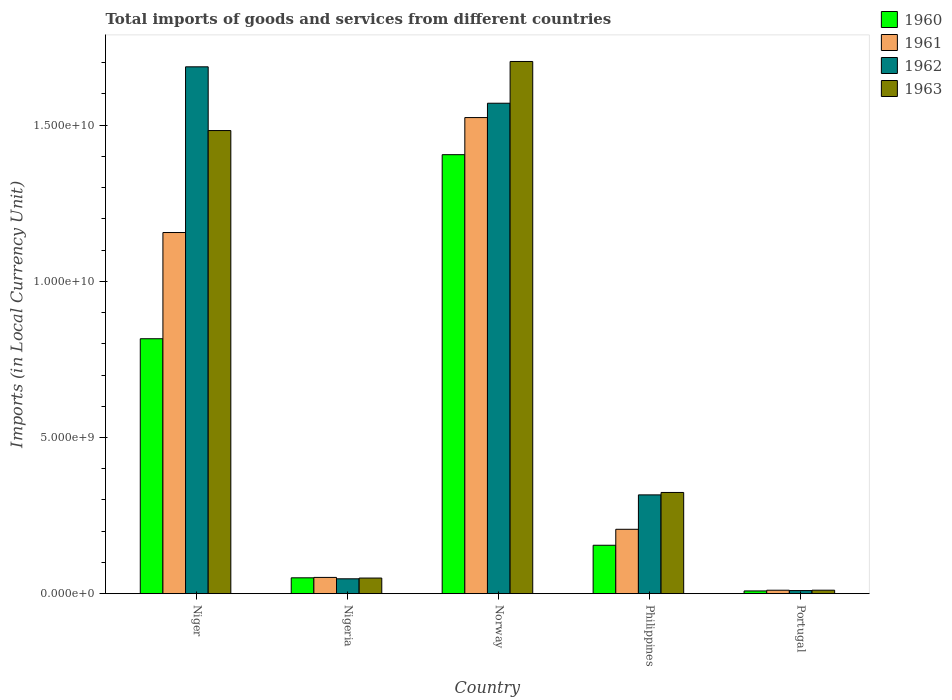How many different coloured bars are there?
Keep it short and to the point. 4. Are the number of bars per tick equal to the number of legend labels?
Offer a very short reply. Yes. Are the number of bars on each tick of the X-axis equal?
Keep it short and to the point. Yes. How many bars are there on the 3rd tick from the left?
Your answer should be very brief. 4. What is the label of the 2nd group of bars from the left?
Ensure brevity in your answer.  Nigeria. What is the Amount of goods and services imports in 1963 in Nigeria?
Your response must be concise. 4.99e+08. Across all countries, what is the maximum Amount of goods and services imports in 1962?
Keep it short and to the point. 1.69e+1. Across all countries, what is the minimum Amount of goods and services imports in 1960?
Ensure brevity in your answer.  8.70e+07. In which country was the Amount of goods and services imports in 1962 maximum?
Provide a succinct answer. Niger. In which country was the Amount of goods and services imports in 1963 minimum?
Keep it short and to the point. Portugal. What is the total Amount of goods and services imports in 1962 in the graph?
Your answer should be very brief. 3.63e+1. What is the difference between the Amount of goods and services imports in 1961 in Nigeria and that in Portugal?
Give a very brief answer. 4.10e+08. What is the difference between the Amount of goods and services imports in 1962 in Norway and the Amount of goods and services imports in 1961 in Nigeria?
Offer a very short reply. 1.52e+1. What is the average Amount of goods and services imports in 1961 per country?
Ensure brevity in your answer.  5.90e+09. What is the difference between the Amount of goods and services imports of/in 1963 and Amount of goods and services imports of/in 1961 in Philippines?
Keep it short and to the point. 1.18e+09. What is the ratio of the Amount of goods and services imports in 1960 in Niger to that in Nigeria?
Your answer should be very brief. 16.09. Is the Amount of goods and services imports in 1961 in Nigeria less than that in Norway?
Provide a short and direct response. Yes. What is the difference between the highest and the second highest Amount of goods and services imports in 1963?
Offer a terse response. 2.21e+09. What is the difference between the highest and the lowest Amount of goods and services imports in 1961?
Ensure brevity in your answer.  1.51e+1. In how many countries, is the Amount of goods and services imports in 1961 greater than the average Amount of goods and services imports in 1961 taken over all countries?
Your answer should be very brief. 2. Is the sum of the Amount of goods and services imports in 1962 in Nigeria and Portugal greater than the maximum Amount of goods and services imports in 1963 across all countries?
Give a very brief answer. No. Is it the case that in every country, the sum of the Amount of goods and services imports in 1962 and Amount of goods and services imports in 1963 is greater than the sum of Amount of goods and services imports in 1961 and Amount of goods and services imports in 1960?
Offer a terse response. No. What does the 2nd bar from the right in Norway represents?
Offer a very short reply. 1962. Is it the case that in every country, the sum of the Amount of goods and services imports in 1960 and Amount of goods and services imports in 1962 is greater than the Amount of goods and services imports in 1963?
Your answer should be very brief. Yes. How many countries are there in the graph?
Your response must be concise. 5. What is the difference between two consecutive major ticks on the Y-axis?
Your answer should be compact. 5.00e+09. Are the values on the major ticks of Y-axis written in scientific E-notation?
Provide a succinct answer. Yes. Does the graph contain grids?
Provide a short and direct response. No. Where does the legend appear in the graph?
Offer a very short reply. Top right. How many legend labels are there?
Keep it short and to the point. 4. What is the title of the graph?
Offer a very short reply. Total imports of goods and services from different countries. What is the label or title of the X-axis?
Make the answer very short. Country. What is the label or title of the Y-axis?
Keep it short and to the point. Imports (in Local Currency Unit). What is the Imports (in Local Currency Unit) in 1960 in Niger?
Give a very brief answer. 8.16e+09. What is the Imports (in Local Currency Unit) of 1961 in Niger?
Provide a short and direct response. 1.16e+1. What is the Imports (in Local Currency Unit) of 1962 in Niger?
Offer a terse response. 1.69e+1. What is the Imports (in Local Currency Unit) of 1963 in Niger?
Your answer should be compact. 1.48e+1. What is the Imports (in Local Currency Unit) of 1960 in Nigeria?
Offer a terse response. 5.07e+08. What is the Imports (in Local Currency Unit) in 1961 in Nigeria?
Offer a terse response. 5.20e+08. What is the Imports (in Local Currency Unit) in 1962 in Nigeria?
Your answer should be compact. 4.76e+08. What is the Imports (in Local Currency Unit) of 1963 in Nigeria?
Ensure brevity in your answer.  4.99e+08. What is the Imports (in Local Currency Unit) of 1960 in Norway?
Your answer should be very brief. 1.41e+1. What is the Imports (in Local Currency Unit) in 1961 in Norway?
Offer a very short reply. 1.52e+1. What is the Imports (in Local Currency Unit) of 1962 in Norway?
Keep it short and to the point. 1.57e+1. What is the Imports (in Local Currency Unit) in 1963 in Norway?
Your answer should be very brief. 1.70e+1. What is the Imports (in Local Currency Unit) of 1960 in Philippines?
Provide a succinct answer. 1.55e+09. What is the Imports (in Local Currency Unit) of 1961 in Philippines?
Ensure brevity in your answer.  2.06e+09. What is the Imports (in Local Currency Unit) in 1962 in Philippines?
Offer a very short reply. 3.16e+09. What is the Imports (in Local Currency Unit) in 1963 in Philippines?
Give a very brief answer. 3.24e+09. What is the Imports (in Local Currency Unit) of 1960 in Portugal?
Provide a succinct answer. 8.70e+07. What is the Imports (in Local Currency Unit) of 1961 in Portugal?
Give a very brief answer. 1.10e+08. What is the Imports (in Local Currency Unit) of 1962 in Portugal?
Offer a terse response. 9.89e+07. What is the Imports (in Local Currency Unit) of 1963 in Portugal?
Ensure brevity in your answer.  1.11e+08. Across all countries, what is the maximum Imports (in Local Currency Unit) in 1960?
Keep it short and to the point. 1.41e+1. Across all countries, what is the maximum Imports (in Local Currency Unit) in 1961?
Your answer should be very brief. 1.52e+1. Across all countries, what is the maximum Imports (in Local Currency Unit) in 1962?
Provide a succinct answer. 1.69e+1. Across all countries, what is the maximum Imports (in Local Currency Unit) of 1963?
Your answer should be compact. 1.70e+1. Across all countries, what is the minimum Imports (in Local Currency Unit) of 1960?
Provide a succinct answer. 8.70e+07. Across all countries, what is the minimum Imports (in Local Currency Unit) of 1961?
Offer a very short reply. 1.10e+08. Across all countries, what is the minimum Imports (in Local Currency Unit) in 1962?
Offer a very short reply. 9.89e+07. Across all countries, what is the minimum Imports (in Local Currency Unit) in 1963?
Provide a succinct answer. 1.11e+08. What is the total Imports (in Local Currency Unit) of 1960 in the graph?
Your answer should be very brief. 2.44e+1. What is the total Imports (in Local Currency Unit) of 1961 in the graph?
Keep it short and to the point. 2.95e+1. What is the total Imports (in Local Currency Unit) of 1962 in the graph?
Provide a short and direct response. 3.63e+1. What is the total Imports (in Local Currency Unit) in 1963 in the graph?
Your answer should be compact. 3.57e+1. What is the difference between the Imports (in Local Currency Unit) of 1960 in Niger and that in Nigeria?
Keep it short and to the point. 7.66e+09. What is the difference between the Imports (in Local Currency Unit) of 1961 in Niger and that in Nigeria?
Provide a succinct answer. 1.10e+1. What is the difference between the Imports (in Local Currency Unit) of 1962 in Niger and that in Nigeria?
Offer a terse response. 1.64e+1. What is the difference between the Imports (in Local Currency Unit) of 1963 in Niger and that in Nigeria?
Offer a terse response. 1.43e+1. What is the difference between the Imports (in Local Currency Unit) of 1960 in Niger and that in Norway?
Your answer should be very brief. -5.89e+09. What is the difference between the Imports (in Local Currency Unit) in 1961 in Niger and that in Norway?
Give a very brief answer. -3.68e+09. What is the difference between the Imports (in Local Currency Unit) of 1962 in Niger and that in Norway?
Offer a terse response. 1.17e+09. What is the difference between the Imports (in Local Currency Unit) in 1963 in Niger and that in Norway?
Make the answer very short. -2.21e+09. What is the difference between the Imports (in Local Currency Unit) of 1960 in Niger and that in Philippines?
Keep it short and to the point. 6.61e+09. What is the difference between the Imports (in Local Currency Unit) in 1961 in Niger and that in Philippines?
Your answer should be compact. 9.50e+09. What is the difference between the Imports (in Local Currency Unit) of 1962 in Niger and that in Philippines?
Offer a terse response. 1.37e+1. What is the difference between the Imports (in Local Currency Unit) of 1963 in Niger and that in Philippines?
Provide a short and direct response. 1.16e+1. What is the difference between the Imports (in Local Currency Unit) in 1960 in Niger and that in Portugal?
Your answer should be compact. 8.08e+09. What is the difference between the Imports (in Local Currency Unit) of 1961 in Niger and that in Portugal?
Your answer should be compact. 1.15e+1. What is the difference between the Imports (in Local Currency Unit) in 1962 in Niger and that in Portugal?
Make the answer very short. 1.68e+1. What is the difference between the Imports (in Local Currency Unit) in 1963 in Niger and that in Portugal?
Your answer should be very brief. 1.47e+1. What is the difference between the Imports (in Local Currency Unit) in 1960 in Nigeria and that in Norway?
Keep it short and to the point. -1.35e+1. What is the difference between the Imports (in Local Currency Unit) in 1961 in Nigeria and that in Norway?
Your answer should be compact. -1.47e+1. What is the difference between the Imports (in Local Currency Unit) in 1962 in Nigeria and that in Norway?
Your answer should be compact. -1.52e+1. What is the difference between the Imports (in Local Currency Unit) of 1963 in Nigeria and that in Norway?
Keep it short and to the point. -1.65e+1. What is the difference between the Imports (in Local Currency Unit) of 1960 in Nigeria and that in Philippines?
Give a very brief answer. -1.04e+09. What is the difference between the Imports (in Local Currency Unit) of 1961 in Nigeria and that in Philippines?
Make the answer very short. -1.54e+09. What is the difference between the Imports (in Local Currency Unit) of 1962 in Nigeria and that in Philippines?
Offer a very short reply. -2.69e+09. What is the difference between the Imports (in Local Currency Unit) in 1963 in Nigeria and that in Philippines?
Offer a very short reply. -2.74e+09. What is the difference between the Imports (in Local Currency Unit) of 1960 in Nigeria and that in Portugal?
Give a very brief answer. 4.20e+08. What is the difference between the Imports (in Local Currency Unit) in 1961 in Nigeria and that in Portugal?
Offer a very short reply. 4.10e+08. What is the difference between the Imports (in Local Currency Unit) of 1962 in Nigeria and that in Portugal?
Your answer should be very brief. 3.77e+08. What is the difference between the Imports (in Local Currency Unit) of 1963 in Nigeria and that in Portugal?
Make the answer very short. 3.89e+08. What is the difference between the Imports (in Local Currency Unit) of 1960 in Norway and that in Philippines?
Provide a short and direct response. 1.25e+1. What is the difference between the Imports (in Local Currency Unit) of 1961 in Norway and that in Philippines?
Ensure brevity in your answer.  1.32e+1. What is the difference between the Imports (in Local Currency Unit) of 1962 in Norway and that in Philippines?
Provide a short and direct response. 1.25e+1. What is the difference between the Imports (in Local Currency Unit) in 1963 in Norway and that in Philippines?
Keep it short and to the point. 1.38e+1. What is the difference between the Imports (in Local Currency Unit) in 1960 in Norway and that in Portugal?
Ensure brevity in your answer.  1.40e+1. What is the difference between the Imports (in Local Currency Unit) of 1961 in Norway and that in Portugal?
Offer a terse response. 1.51e+1. What is the difference between the Imports (in Local Currency Unit) in 1962 in Norway and that in Portugal?
Offer a terse response. 1.56e+1. What is the difference between the Imports (in Local Currency Unit) of 1963 in Norway and that in Portugal?
Offer a terse response. 1.69e+1. What is the difference between the Imports (in Local Currency Unit) of 1960 in Philippines and that in Portugal?
Your answer should be very brief. 1.46e+09. What is the difference between the Imports (in Local Currency Unit) of 1961 in Philippines and that in Portugal?
Ensure brevity in your answer.  1.95e+09. What is the difference between the Imports (in Local Currency Unit) in 1962 in Philippines and that in Portugal?
Provide a succinct answer. 3.06e+09. What is the difference between the Imports (in Local Currency Unit) of 1963 in Philippines and that in Portugal?
Offer a terse response. 3.13e+09. What is the difference between the Imports (in Local Currency Unit) of 1960 in Niger and the Imports (in Local Currency Unit) of 1961 in Nigeria?
Ensure brevity in your answer.  7.64e+09. What is the difference between the Imports (in Local Currency Unit) of 1960 in Niger and the Imports (in Local Currency Unit) of 1962 in Nigeria?
Your response must be concise. 7.69e+09. What is the difference between the Imports (in Local Currency Unit) of 1960 in Niger and the Imports (in Local Currency Unit) of 1963 in Nigeria?
Provide a succinct answer. 7.66e+09. What is the difference between the Imports (in Local Currency Unit) of 1961 in Niger and the Imports (in Local Currency Unit) of 1962 in Nigeria?
Your answer should be very brief. 1.11e+1. What is the difference between the Imports (in Local Currency Unit) in 1961 in Niger and the Imports (in Local Currency Unit) in 1963 in Nigeria?
Offer a terse response. 1.11e+1. What is the difference between the Imports (in Local Currency Unit) of 1962 in Niger and the Imports (in Local Currency Unit) of 1963 in Nigeria?
Provide a succinct answer. 1.64e+1. What is the difference between the Imports (in Local Currency Unit) in 1960 in Niger and the Imports (in Local Currency Unit) in 1961 in Norway?
Ensure brevity in your answer.  -7.08e+09. What is the difference between the Imports (in Local Currency Unit) in 1960 in Niger and the Imports (in Local Currency Unit) in 1962 in Norway?
Provide a short and direct response. -7.54e+09. What is the difference between the Imports (in Local Currency Unit) in 1960 in Niger and the Imports (in Local Currency Unit) in 1963 in Norway?
Provide a succinct answer. -8.88e+09. What is the difference between the Imports (in Local Currency Unit) in 1961 in Niger and the Imports (in Local Currency Unit) in 1962 in Norway?
Your response must be concise. -4.14e+09. What is the difference between the Imports (in Local Currency Unit) in 1961 in Niger and the Imports (in Local Currency Unit) in 1963 in Norway?
Make the answer very short. -5.48e+09. What is the difference between the Imports (in Local Currency Unit) of 1962 in Niger and the Imports (in Local Currency Unit) of 1963 in Norway?
Offer a terse response. -1.71e+08. What is the difference between the Imports (in Local Currency Unit) of 1960 in Niger and the Imports (in Local Currency Unit) of 1961 in Philippines?
Your answer should be compact. 6.10e+09. What is the difference between the Imports (in Local Currency Unit) of 1960 in Niger and the Imports (in Local Currency Unit) of 1962 in Philippines?
Make the answer very short. 5.00e+09. What is the difference between the Imports (in Local Currency Unit) in 1960 in Niger and the Imports (in Local Currency Unit) in 1963 in Philippines?
Ensure brevity in your answer.  4.92e+09. What is the difference between the Imports (in Local Currency Unit) of 1961 in Niger and the Imports (in Local Currency Unit) of 1962 in Philippines?
Provide a succinct answer. 8.40e+09. What is the difference between the Imports (in Local Currency Unit) in 1961 in Niger and the Imports (in Local Currency Unit) in 1963 in Philippines?
Provide a short and direct response. 8.32e+09. What is the difference between the Imports (in Local Currency Unit) of 1962 in Niger and the Imports (in Local Currency Unit) of 1963 in Philippines?
Offer a terse response. 1.36e+1. What is the difference between the Imports (in Local Currency Unit) in 1960 in Niger and the Imports (in Local Currency Unit) in 1961 in Portugal?
Keep it short and to the point. 8.05e+09. What is the difference between the Imports (in Local Currency Unit) in 1960 in Niger and the Imports (in Local Currency Unit) in 1962 in Portugal?
Make the answer very short. 8.06e+09. What is the difference between the Imports (in Local Currency Unit) of 1960 in Niger and the Imports (in Local Currency Unit) of 1963 in Portugal?
Give a very brief answer. 8.05e+09. What is the difference between the Imports (in Local Currency Unit) of 1961 in Niger and the Imports (in Local Currency Unit) of 1962 in Portugal?
Offer a very short reply. 1.15e+1. What is the difference between the Imports (in Local Currency Unit) in 1961 in Niger and the Imports (in Local Currency Unit) in 1963 in Portugal?
Your answer should be very brief. 1.15e+1. What is the difference between the Imports (in Local Currency Unit) in 1962 in Niger and the Imports (in Local Currency Unit) in 1963 in Portugal?
Keep it short and to the point. 1.68e+1. What is the difference between the Imports (in Local Currency Unit) in 1960 in Nigeria and the Imports (in Local Currency Unit) in 1961 in Norway?
Your response must be concise. -1.47e+1. What is the difference between the Imports (in Local Currency Unit) of 1960 in Nigeria and the Imports (in Local Currency Unit) of 1962 in Norway?
Offer a terse response. -1.52e+1. What is the difference between the Imports (in Local Currency Unit) in 1960 in Nigeria and the Imports (in Local Currency Unit) in 1963 in Norway?
Keep it short and to the point. -1.65e+1. What is the difference between the Imports (in Local Currency Unit) in 1961 in Nigeria and the Imports (in Local Currency Unit) in 1962 in Norway?
Provide a succinct answer. -1.52e+1. What is the difference between the Imports (in Local Currency Unit) in 1961 in Nigeria and the Imports (in Local Currency Unit) in 1963 in Norway?
Your response must be concise. -1.65e+1. What is the difference between the Imports (in Local Currency Unit) of 1962 in Nigeria and the Imports (in Local Currency Unit) of 1963 in Norway?
Provide a succinct answer. -1.66e+1. What is the difference between the Imports (in Local Currency Unit) in 1960 in Nigeria and the Imports (in Local Currency Unit) in 1961 in Philippines?
Your answer should be compact. -1.55e+09. What is the difference between the Imports (in Local Currency Unit) in 1960 in Nigeria and the Imports (in Local Currency Unit) in 1962 in Philippines?
Keep it short and to the point. -2.66e+09. What is the difference between the Imports (in Local Currency Unit) of 1960 in Nigeria and the Imports (in Local Currency Unit) of 1963 in Philippines?
Provide a succinct answer. -2.73e+09. What is the difference between the Imports (in Local Currency Unit) of 1961 in Nigeria and the Imports (in Local Currency Unit) of 1962 in Philippines?
Provide a succinct answer. -2.64e+09. What is the difference between the Imports (in Local Currency Unit) of 1961 in Nigeria and the Imports (in Local Currency Unit) of 1963 in Philippines?
Offer a terse response. -2.72e+09. What is the difference between the Imports (in Local Currency Unit) of 1962 in Nigeria and the Imports (in Local Currency Unit) of 1963 in Philippines?
Offer a very short reply. -2.76e+09. What is the difference between the Imports (in Local Currency Unit) in 1960 in Nigeria and the Imports (in Local Currency Unit) in 1961 in Portugal?
Your response must be concise. 3.98e+08. What is the difference between the Imports (in Local Currency Unit) in 1960 in Nigeria and the Imports (in Local Currency Unit) in 1962 in Portugal?
Give a very brief answer. 4.08e+08. What is the difference between the Imports (in Local Currency Unit) in 1960 in Nigeria and the Imports (in Local Currency Unit) in 1963 in Portugal?
Your response must be concise. 3.97e+08. What is the difference between the Imports (in Local Currency Unit) in 1961 in Nigeria and the Imports (in Local Currency Unit) in 1962 in Portugal?
Your answer should be very brief. 4.21e+08. What is the difference between the Imports (in Local Currency Unit) in 1961 in Nigeria and the Imports (in Local Currency Unit) in 1963 in Portugal?
Keep it short and to the point. 4.09e+08. What is the difference between the Imports (in Local Currency Unit) of 1962 in Nigeria and the Imports (in Local Currency Unit) of 1963 in Portugal?
Keep it short and to the point. 3.65e+08. What is the difference between the Imports (in Local Currency Unit) of 1960 in Norway and the Imports (in Local Currency Unit) of 1961 in Philippines?
Provide a succinct answer. 1.20e+1. What is the difference between the Imports (in Local Currency Unit) in 1960 in Norway and the Imports (in Local Currency Unit) in 1962 in Philippines?
Keep it short and to the point. 1.09e+1. What is the difference between the Imports (in Local Currency Unit) of 1960 in Norway and the Imports (in Local Currency Unit) of 1963 in Philippines?
Provide a succinct answer. 1.08e+1. What is the difference between the Imports (in Local Currency Unit) in 1961 in Norway and the Imports (in Local Currency Unit) in 1962 in Philippines?
Your answer should be compact. 1.21e+1. What is the difference between the Imports (in Local Currency Unit) of 1961 in Norway and the Imports (in Local Currency Unit) of 1963 in Philippines?
Offer a terse response. 1.20e+1. What is the difference between the Imports (in Local Currency Unit) in 1962 in Norway and the Imports (in Local Currency Unit) in 1963 in Philippines?
Your response must be concise. 1.25e+1. What is the difference between the Imports (in Local Currency Unit) in 1960 in Norway and the Imports (in Local Currency Unit) in 1961 in Portugal?
Your answer should be compact. 1.39e+1. What is the difference between the Imports (in Local Currency Unit) of 1960 in Norway and the Imports (in Local Currency Unit) of 1962 in Portugal?
Keep it short and to the point. 1.40e+1. What is the difference between the Imports (in Local Currency Unit) in 1960 in Norway and the Imports (in Local Currency Unit) in 1963 in Portugal?
Give a very brief answer. 1.39e+1. What is the difference between the Imports (in Local Currency Unit) of 1961 in Norway and the Imports (in Local Currency Unit) of 1962 in Portugal?
Ensure brevity in your answer.  1.51e+1. What is the difference between the Imports (in Local Currency Unit) of 1961 in Norway and the Imports (in Local Currency Unit) of 1963 in Portugal?
Ensure brevity in your answer.  1.51e+1. What is the difference between the Imports (in Local Currency Unit) in 1962 in Norway and the Imports (in Local Currency Unit) in 1963 in Portugal?
Your answer should be compact. 1.56e+1. What is the difference between the Imports (in Local Currency Unit) of 1960 in Philippines and the Imports (in Local Currency Unit) of 1961 in Portugal?
Your response must be concise. 1.44e+09. What is the difference between the Imports (in Local Currency Unit) of 1960 in Philippines and the Imports (in Local Currency Unit) of 1962 in Portugal?
Your response must be concise. 1.45e+09. What is the difference between the Imports (in Local Currency Unit) in 1960 in Philippines and the Imports (in Local Currency Unit) in 1963 in Portugal?
Your answer should be compact. 1.44e+09. What is the difference between the Imports (in Local Currency Unit) of 1961 in Philippines and the Imports (in Local Currency Unit) of 1962 in Portugal?
Ensure brevity in your answer.  1.96e+09. What is the difference between the Imports (in Local Currency Unit) in 1961 in Philippines and the Imports (in Local Currency Unit) in 1963 in Portugal?
Give a very brief answer. 1.95e+09. What is the difference between the Imports (in Local Currency Unit) of 1962 in Philippines and the Imports (in Local Currency Unit) of 1963 in Portugal?
Keep it short and to the point. 3.05e+09. What is the average Imports (in Local Currency Unit) of 1960 per country?
Provide a succinct answer. 4.87e+09. What is the average Imports (in Local Currency Unit) in 1961 per country?
Provide a succinct answer. 5.90e+09. What is the average Imports (in Local Currency Unit) in 1962 per country?
Provide a succinct answer. 7.26e+09. What is the average Imports (in Local Currency Unit) in 1963 per country?
Provide a succinct answer. 7.14e+09. What is the difference between the Imports (in Local Currency Unit) in 1960 and Imports (in Local Currency Unit) in 1961 in Niger?
Give a very brief answer. -3.40e+09. What is the difference between the Imports (in Local Currency Unit) of 1960 and Imports (in Local Currency Unit) of 1962 in Niger?
Offer a terse response. -8.71e+09. What is the difference between the Imports (in Local Currency Unit) in 1960 and Imports (in Local Currency Unit) in 1963 in Niger?
Offer a terse response. -6.67e+09. What is the difference between the Imports (in Local Currency Unit) in 1961 and Imports (in Local Currency Unit) in 1962 in Niger?
Ensure brevity in your answer.  -5.31e+09. What is the difference between the Imports (in Local Currency Unit) in 1961 and Imports (in Local Currency Unit) in 1963 in Niger?
Make the answer very short. -3.26e+09. What is the difference between the Imports (in Local Currency Unit) in 1962 and Imports (in Local Currency Unit) in 1963 in Niger?
Give a very brief answer. 2.04e+09. What is the difference between the Imports (in Local Currency Unit) of 1960 and Imports (in Local Currency Unit) of 1961 in Nigeria?
Provide a short and direct response. -1.28e+07. What is the difference between the Imports (in Local Currency Unit) in 1960 and Imports (in Local Currency Unit) in 1962 in Nigeria?
Provide a short and direct response. 3.18e+07. What is the difference between the Imports (in Local Currency Unit) in 1960 and Imports (in Local Currency Unit) in 1963 in Nigeria?
Give a very brief answer. 7.80e+06. What is the difference between the Imports (in Local Currency Unit) of 1961 and Imports (in Local Currency Unit) of 1962 in Nigeria?
Your answer should be compact. 4.46e+07. What is the difference between the Imports (in Local Currency Unit) of 1961 and Imports (in Local Currency Unit) of 1963 in Nigeria?
Your answer should be very brief. 2.06e+07. What is the difference between the Imports (in Local Currency Unit) of 1962 and Imports (in Local Currency Unit) of 1963 in Nigeria?
Your response must be concise. -2.40e+07. What is the difference between the Imports (in Local Currency Unit) of 1960 and Imports (in Local Currency Unit) of 1961 in Norway?
Provide a succinct answer. -1.19e+09. What is the difference between the Imports (in Local Currency Unit) in 1960 and Imports (in Local Currency Unit) in 1962 in Norway?
Keep it short and to the point. -1.65e+09. What is the difference between the Imports (in Local Currency Unit) of 1960 and Imports (in Local Currency Unit) of 1963 in Norway?
Provide a succinct answer. -2.98e+09. What is the difference between the Imports (in Local Currency Unit) in 1961 and Imports (in Local Currency Unit) in 1962 in Norway?
Offer a terse response. -4.60e+08. What is the difference between the Imports (in Local Currency Unit) of 1961 and Imports (in Local Currency Unit) of 1963 in Norway?
Give a very brief answer. -1.80e+09. What is the difference between the Imports (in Local Currency Unit) in 1962 and Imports (in Local Currency Unit) in 1963 in Norway?
Your answer should be very brief. -1.34e+09. What is the difference between the Imports (in Local Currency Unit) in 1960 and Imports (in Local Currency Unit) in 1961 in Philippines?
Provide a succinct answer. -5.12e+08. What is the difference between the Imports (in Local Currency Unit) of 1960 and Imports (in Local Currency Unit) of 1962 in Philippines?
Offer a terse response. -1.61e+09. What is the difference between the Imports (in Local Currency Unit) in 1960 and Imports (in Local Currency Unit) in 1963 in Philippines?
Your answer should be compact. -1.69e+09. What is the difference between the Imports (in Local Currency Unit) of 1961 and Imports (in Local Currency Unit) of 1962 in Philippines?
Give a very brief answer. -1.10e+09. What is the difference between the Imports (in Local Currency Unit) in 1961 and Imports (in Local Currency Unit) in 1963 in Philippines?
Offer a terse response. -1.18e+09. What is the difference between the Imports (in Local Currency Unit) of 1962 and Imports (in Local Currency Unit) of 1963 in Philippines?
Your response must be concise. -7.75e+07. What is the difference between the Imports (in Local Currency Unit) in 1960 and Imports (in Local Currency Unit) in 1961 in Portugal?
Your answer should be very brief. -2.27e+07. What is the difference between the Imports (in Local Currency Unit) in 1960 and Imports (in Local Currency Unit) in 1962 in Portugal?
Your response must be concise. -1.18e+07. What is the difference between the Imports (in Local Currency Unit) of 1960 and Imports (in Local Currency Unit) of 1963 in Portugal?
Your answer should be compact. -2.37e+07. What is the difference between the Imports (in Local Currency Unit) in 1961 and Imports (in Local Currency Unit) in 1962 in Portugal?
Keep it short and to the point. 1.08e+07. What is the difference between the Imports (in Local Currency Unit) of 1961 and Imports (in Local Currency Unit) of 1963 in Portugal?
Provide a short and direct response. -1.03e+06. What is the difference between the Imports (in Local Currency Unit) in 1962 and Imports (in Local Currency Unit) in 1963 in Portugal?
Give a very brief answer. -1.18e+07. What is the ratio of the Imports (in Local Currency Unit) in 1960 in Niger to that in Nigeria?
Provide a succinct answer. 16.09. What is the ratio of the Imports (in Local Currency Unit) in 1961 in Niger to that in Nigeria?
Ensure brevity in your answer.  22.23. What is the ratio of the Imports (in Local Currency Unit) of 1962 in Niger to that in Nigeria?
Ensure brevity in your answer.  35.47. What is the ratio of the Imports (in Local Currency Unit) in 1963 in Niger to that in Nigeria?
Your answer should be very brief. 29.69. What is the ratio of the Imports (in Local Currency Unit) in 1960 in Niger to that in Norway?
Offer a terse response. 0.58. What is the ratio of the Imports (in Local Currency Unit) in 1961 in Niger to that in Norway?
Offer a terse response. 0.76. What is the ratio of the Imports (in Local Currency Unit) in 1962 in Niger to that in Norway?
Your answer should be very brief. 1.07. What is the ratio of the Imports (in Local Currency Unit) of 1963 in Niger to that in Norway?
Your answer should be compact. 0.87. What is the ratio of the Imports (in Local Currency Unit) in 1960 in Niger to that in Philippines?
Offer a terse response. 5.27. What is the ratio of the Imports (in Local Currency Unit) of 1961 in Niger to that in Philippines?
Ensure brevity in your answer.  5.61. What is the ratio of the Imports (in Local Currency Unit) of 1962 in Niger to that in Philippines?
Keep it short and to the point. 5.33. What is the ratio of the Imports (in Local Currency Unit) of 1963 in Niger to that in Philippines?
Your response must be concise. 4.58. What is the ratio of the Imports (in Local Currency Unit) of 1960 in Niger to that in Portugal?
Your answer should be very brief. 93.77. What is the ratio of the Imports (in Local Currency Unit) in 1961 in Niger to that in Portugal?
Your answer should be very brief. 105.4. What is the ratio of the Imports (in Local Currency Unit) of 1962 in Niger to that in Portugal?
Ensure brevity in your answer.  170.57. What is the ratio of the Imports (in Local Currency Unit) of 1963 in Niger to that in Portugal?
Offer a terse response. 133.9. What is the ratio of the Imports (in Local Currency Unit) in 1960 in Nigeria to that in Norway?
Your answer should be compact. 0.04. What is the ratio of the Imports (in Local Currency Unit) in 1961 in Nigeria to that in Norway?
Offer a terse response. 0.03. What is the ratio of the Imports (in Local Currency Unit) of 1962 in Nigeria to that in Norway?
Your answer should be compact. 0.03. What is the ratio of the Imports (in Local Currency Unit) of 1963 in Nigeria to that in Norway?
Make the answer very short. 0.03. What is the ratio of the Imports (in Local Currency Unit) of 1960 in Nigeria to that in Philippines?
Your answer should be very brief. 0.33. What is the ratio of the Imports (in Local Currency Unit) in 1961 in Nigeria to that in Philippines?
Give a very brief answer. 0.25. What is the ratio of the Imports (in Local Currency Unit) of 1962 in Nigeria to that in Philippines?
Provide a short and direct response. 0.15. What is the ratio of the Imports (in Local Currency Unit) of 1963 in Nigeria to that in Philippines?
Keep it short and to the point. 0.15. What is the ratio of the Imports (in Local Currency Unit) in 1960 in Nigeria to that in Portugal?
Give a very brief answer. 5.83. What is the ratio of the Imports (in Local Currency Unit) of 1961 in Nigeria to that in Portugal?
Offer a terse response. 4.74. What is the ratio of the Imports (in Local Currency Unit) in 1962 in Nigeria to that in Portugal?
Your answer should be compact. 4.81. What is the ratio of the Imports (in Local Currency Unit) in 1963 in Nigeria to that in Portugal?
Provide a succinct answer. 4.51. What is the ratio of the Imports (in Local Currency Unit) of 1960 in Norway to that in Philippines?
Provide a short and direct response. 9.07. What is the ratio of the Imports (in Local Currency Unit) in 1961 in Norway to that in Philippines?
Keep it short and to the point. 7.4. What is the ratio of the Imports (in Local Currency Unit) in 1962 in Norway to that in Philippines?
Give a very brief answer. 4.96. What is the ratio of the Imports (in Local Currency Unit) in 1963 in Norway to that in Philippines?
Offer a terse response. 5.26. What is the ratio of the Imports (in Local Currency Unit) of 1960 in Norway to that in Portugal?
Your answer should be very brief. 161.47. What is the ratio of the Imports (in Local Currency Unit) in 1961 in Norway to that in Portugal?
Offer a terse response. 138.95. What is the ratio of the Imports (in Local Currency Unit) in 1962 in Norway to that in Portugal?
Your response must be concise. 158.79. What is the ratio of the Imports (in Local Currency Unit) of 1963 in Norway to that in Portugal?
Your answer should be compact. 153.87. What is the ratio of the Imports (in Local Currency Unit) of 1960 in Philippines to that in Portugal?
Make the answer very short. 17.8. What is the ratio of the Imports (in Local Currency Unit) of 1961 in Philippines to that in Portugal?
Ensure brevity in your answer.  18.79. What is the ratio of the Imports (in Local Currency Unit) of 1962 in Philippines to that in Portugal?
Make the answer very short. 31.98. What is the ratio of the Imports (in Local Currency Unit) of 1963 in Philippines to that in Portugal?
Keep it short and to the point. 29.26. What is the difference between the highest and the second highest Imports (in Local Currency Unit) in 1960?
Your answer should be compact. 5.89e+09. What is the difference between the highest and the second highest Imports (in Local Currency Unit) of 1961?
Provide a succinct answer. 3.68e+09. What is the difference between the highest and the second highest Imports (in Local Currency Unit) in 1962?
Keep it short and to the point. 1.17e+09. What is the difference between the highest and the second highest Imports (in Local Currency Unit) of 1963?
Offer a terse response. 2.21e+09. What is the difference between the highest and the lowest Imports (in Local Currency Unit) in 1960?
Your answer should be compact. 1.40e+1. What is the difference between the highest and the lowest Imports (in Local Currency Unit) of 1961?
Offer a very short reply. 1.51e+1. What is the difference between the highest and the lowest Imports (in Local Currency Unit) of 1962?
Your answer should be compact. 1.68e+1. What is the difference between the highest and the lowest Imports (in Local Currency Unit) of 1963?
Provide a short and direct response. 1.69e+1. 